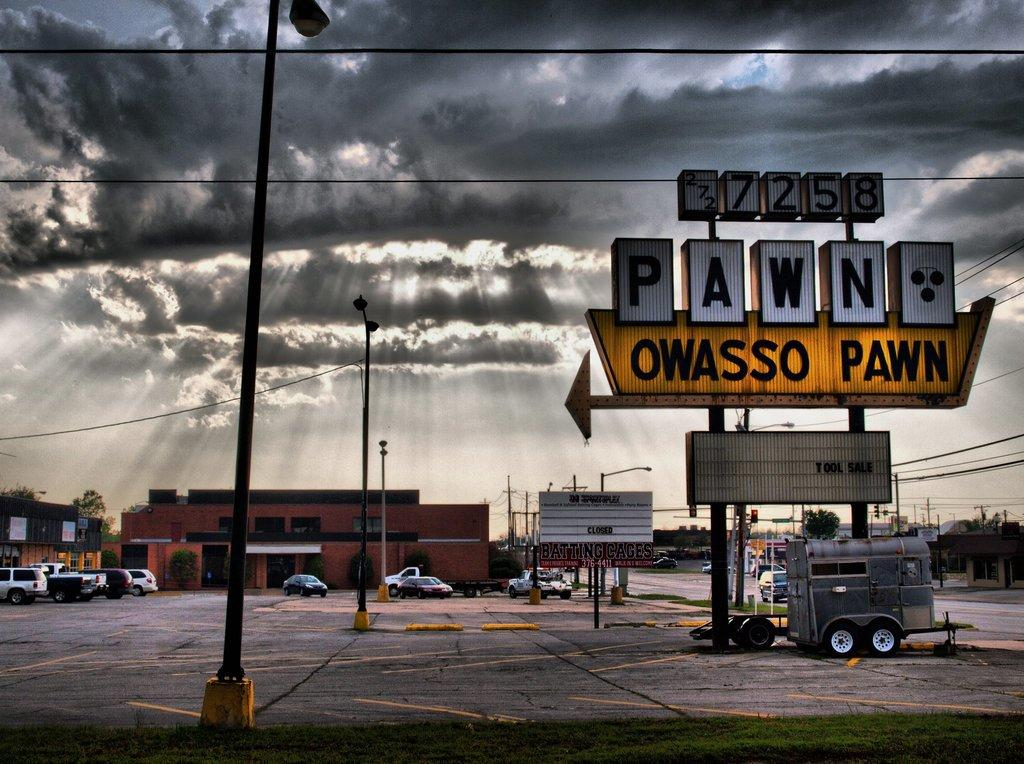What type of vegetation can be seen in the image? There is grass in the image. What type of signs are present in the image? There are name boards in the image. What type of structures can be seen in the image? There are poles in the image. What type of infrastructure can be seen in the image? There are wires in the image. What type of transportation is visible in the image? There are vehicles on the road in the image. What type of natural elements can be seen in the image? There are trees in the image. What type of man-made structures can be seen in the image? There are buildings in the image. What type of objects are present in the image? There are some objects in the image. What can be seen in the background of the image? The sky is visible in the background of the image, and there are clouds in the sky. What type of rhythm can be heard coming from the part in the image? There is no part or rhythm present in the image; it features a scene with grass, name boards, poles, wires, vehicles, trees, buildings, objects, and a sky with clouds. 